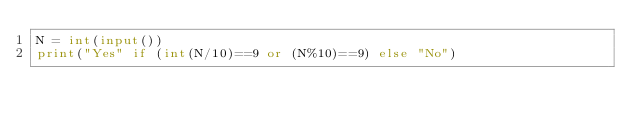Convert code to text. <code><loc_0><loc_0><loc_500><loc_500><_Python_>N = int(input())
print("Yes" if (int(N/10)==9 or (N%10)==9) else "No")</code> 